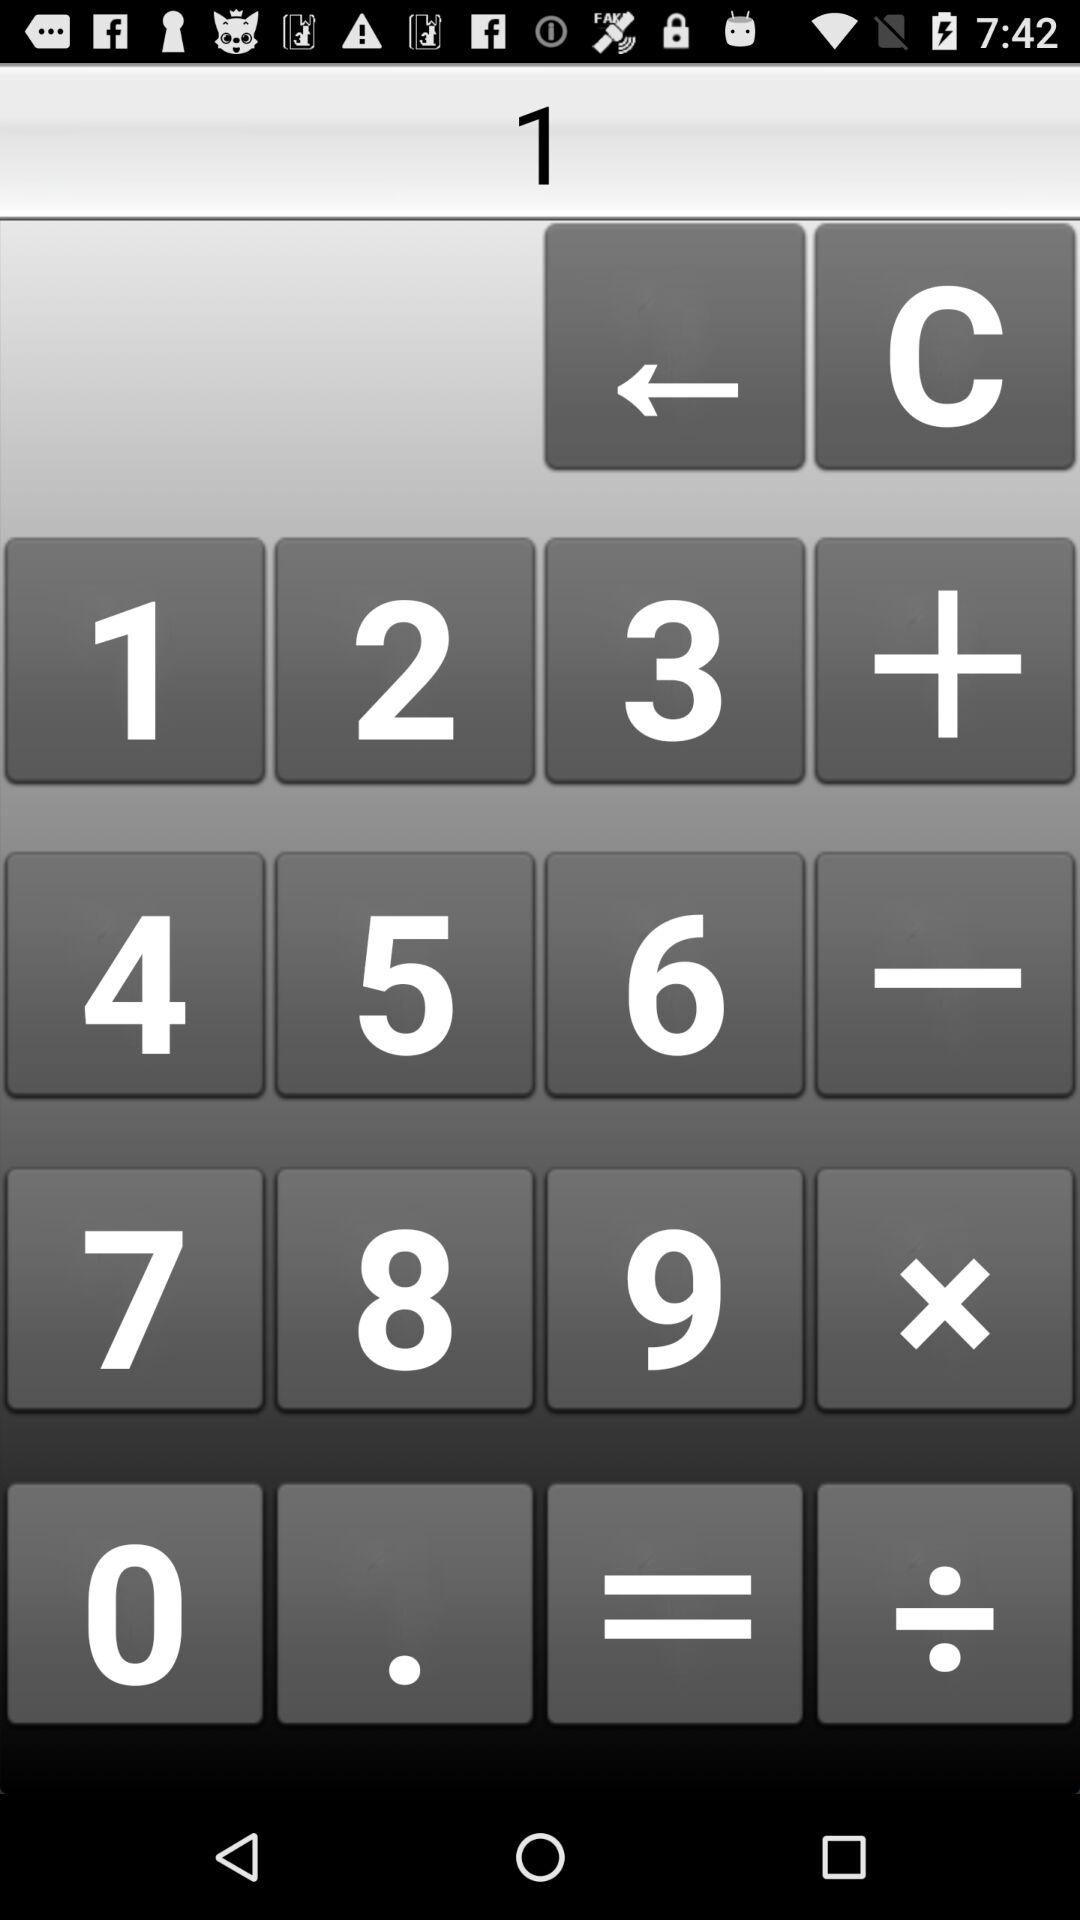What digit is written in the calculator's type section? The written digit in the calculator's type section is 1. 